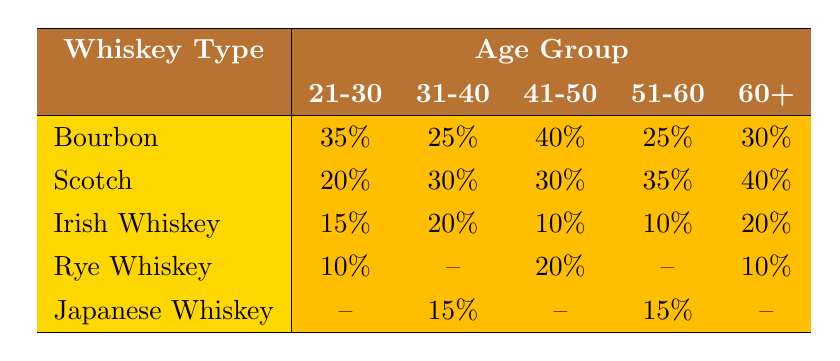What is the most preferred whiskey type among the 21-30 age group? The preference percentage for each whiskey type among the 21-30 age group is as follows: Bourbon 35%, Scotch 20%, Irish Whiskey 15%, Rye Whiskey 10%, Japanese Whiskey is not listed. The highest preference is for Bourbon at 35%.
Answer: Bourbon How many age groups prefer Scotch more than 30%? Looking at the table, the preference percentages for Scotch are: 21-30: 20%, 31-40: 30%, 41-50: 30%, 51-60: 35%, 60+: 40%. Only the 51-60 and 60+ age groups have preferences over 30%. Therefore, there are 2 age groups that prefer Scotch more than 30%.
Answer: 2 Which whiskey type has the lowest overall preference across all age groups? We will look at the preference percentages for each whiskey type: Bourbon averages are 25%, Scotch averages are 30%, Irish Whiskey averages are 15%, Rye Whiskey averages are 10%, Japanese Whiskey has a single preference of 15%. The lowest overall preference is for Rye Whiskey with 10%.
Answer: Rye Whiskey What is the average preference percentage for Irish Whiskey across all age groups? The preference percentages for Irish Whiskey are: 21-30: 15%, 31-40: 20%, 41-50: 10%, 51-60: 10%, and 60+: 20%. Adding these percentages gives 15 + 20 + 10 + 10 + 20 = 85%. Dividing this sum by the number of data points (5), we get an average of 85/5 = 17%.
Answer: 17% Is it true that Bourbon is the most preferred whiskey type for the 41-50 age group? The preference percentage for Bourbon in the 41-50 age group is 40%, while Scotch has 30%, Irish Whiskey has 10%, and Rye Whiskey has 20%. Bourbon is indeed the most preferred whiskey type in this age group.
Answer: Yes Which whiskey type has a preference percentage of 15% in the 31-40 age group? Checking the table, Bourbon has 25%, Scotch has 30%, Irish Whiskey has 20%, Rye Whiskey is not listed, and Japanese Whiskey has 15%. Only Japanese Whiskey has a preference percentage of 15% in the 31-40 age group.
Answer: Japanese Whiskey What is the difference in preference percentage for Scotch between the 60+ and 51-60 age groups? The preference percentage for Scotch in the 60+ age group is 40%, while in the 51-60 age group it is 35%. Subtracting these values gives 40 - 35 = 5%. Hence, the difference in preference percentage for Scotch between these two age groups is 5%.
Answer: 5% Which age group shows a preference for Rye Whiskey? The preference percentages for Rye Whiskey are as follows: 21-30: 10% (listed), 31-40: not listed, 41-50: 20% (listed), 51-60: not listed, 60+: 10% (listed). Rye Whiskey is indicated only in the 21-30, 41-50, and 60+ age groups.
Answer: 21-30, 41-50, 60+ 